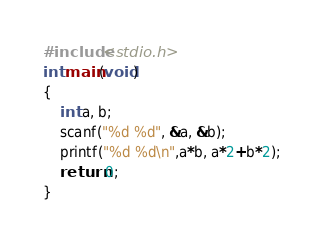Convert code to text. <code><loc_0><loc_0><loc_500><loc_500><_C_>#include<stdio.h>
int main(void)
{
    int a, b;
    scanf("%d %d", &a, &b);
    printf("%d %d\n",a*b, a*2+b*2);
    return 0;
}</code> 